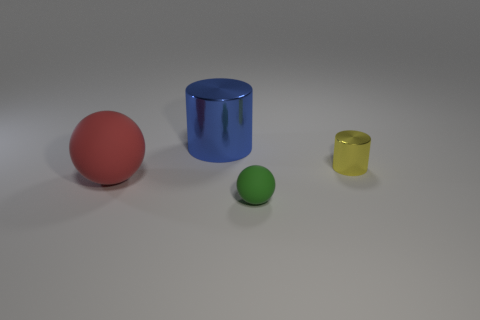How many things are both left of the tiny yellow cylinder and behind the red sphere?
Your answer should be very brief. 1. Is the number of tiny metal cylinders behind the large rubber thing less than the number of tiny blue matte blocks?
Your answer should be compact. No. Are there any things that have the same size as the red matte sphere?
Ensure brevity in your answer.  Yes. There is a tiny ball that is made of the same material as the large red object; what is its color?
Make the answer very short. Green. There is a big thing behind the small yellow object; what number of red matte objects are behind it?
Your answer should be compact. 0. What material is the thing that is in front of the blue metal cylinder and on the left side of the green object?
Offer a very short reply. Rubber. Is the shape of the rubber thing that is to the left of the small sphere the same as  the blue thing?
Your answer should be compact. No. Is the number of red rubber objects less than the number of tiny brown matte balls?
Your answer should be compact. No. Are there more small things than objects?
Make the answer very short. No. What size is the red rubber thing that is the same shape as the small green rubber thing?
Give a very brief answer. Large. 